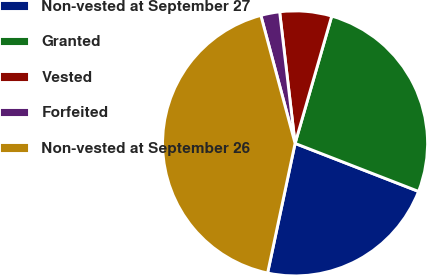Convert chart to OTSL. <chart><loc_0><loc_0><loc_500><loc_500><pie_chart><fcel>Non-vested at September 27<fcel>Granted<fcel>Vested<fcel>Forfeited<fcel>Non-vested at September 26<nl><fcel>22.42%<fcel>26.44%<fcel>6.32%<fcel>2.3%<fcel>42.51%<nl></chart> 